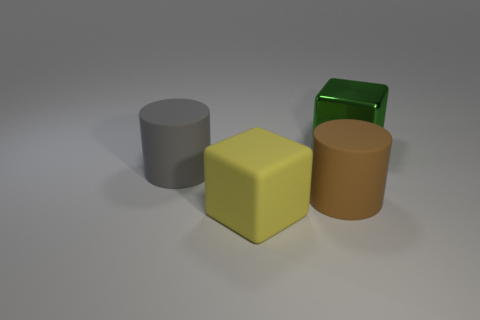What color is the big rubber object that is both behind the yellow object and in front of the gray matte object? The large rubber object situated behind the yellow cube and in front of the gray cylinder is a rich shade of brown. 